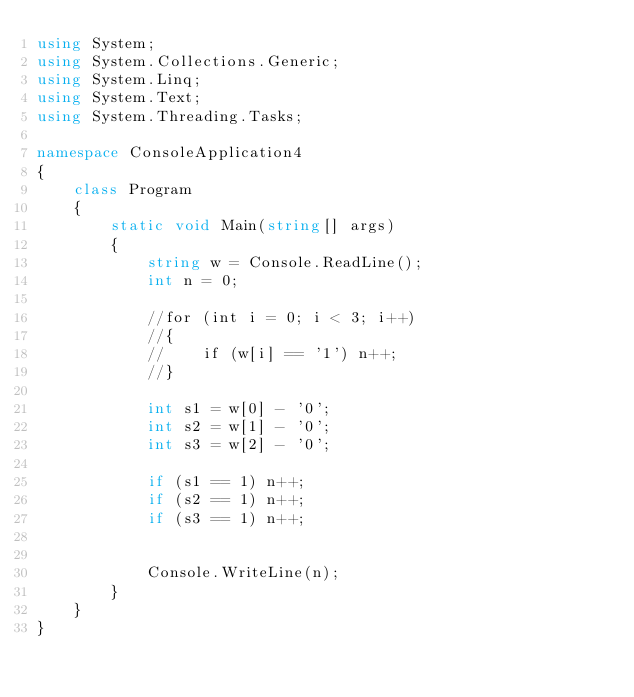Convert code to text. <code><loc_0><loc_0><loc_500><loc_500><_C#_>using System;
using System.Collections.Generic;
using System.Linq;
using System.Text;
using System.Threading.Tasks;

namespace ConsoleApplication4
{
    class Program
    {
        static void Main(string[] args)
        {
            string w = Console.ReadLine();
            int n = 0;

            //for (int i = 0; i < 3; i++)
            //{
            //    if (w[i] == '1') n++;
            //}

            int s1 = w[0] - '0';
            int s2 = w[1] - '0';
            int s3 = w[2] - '0';

            if (s1 == 1) n++;
            if (s2 == 1) n++;
            if (s3 == 1) n++;


            Console.WriteLine(n);
        }
    }
}</code> 